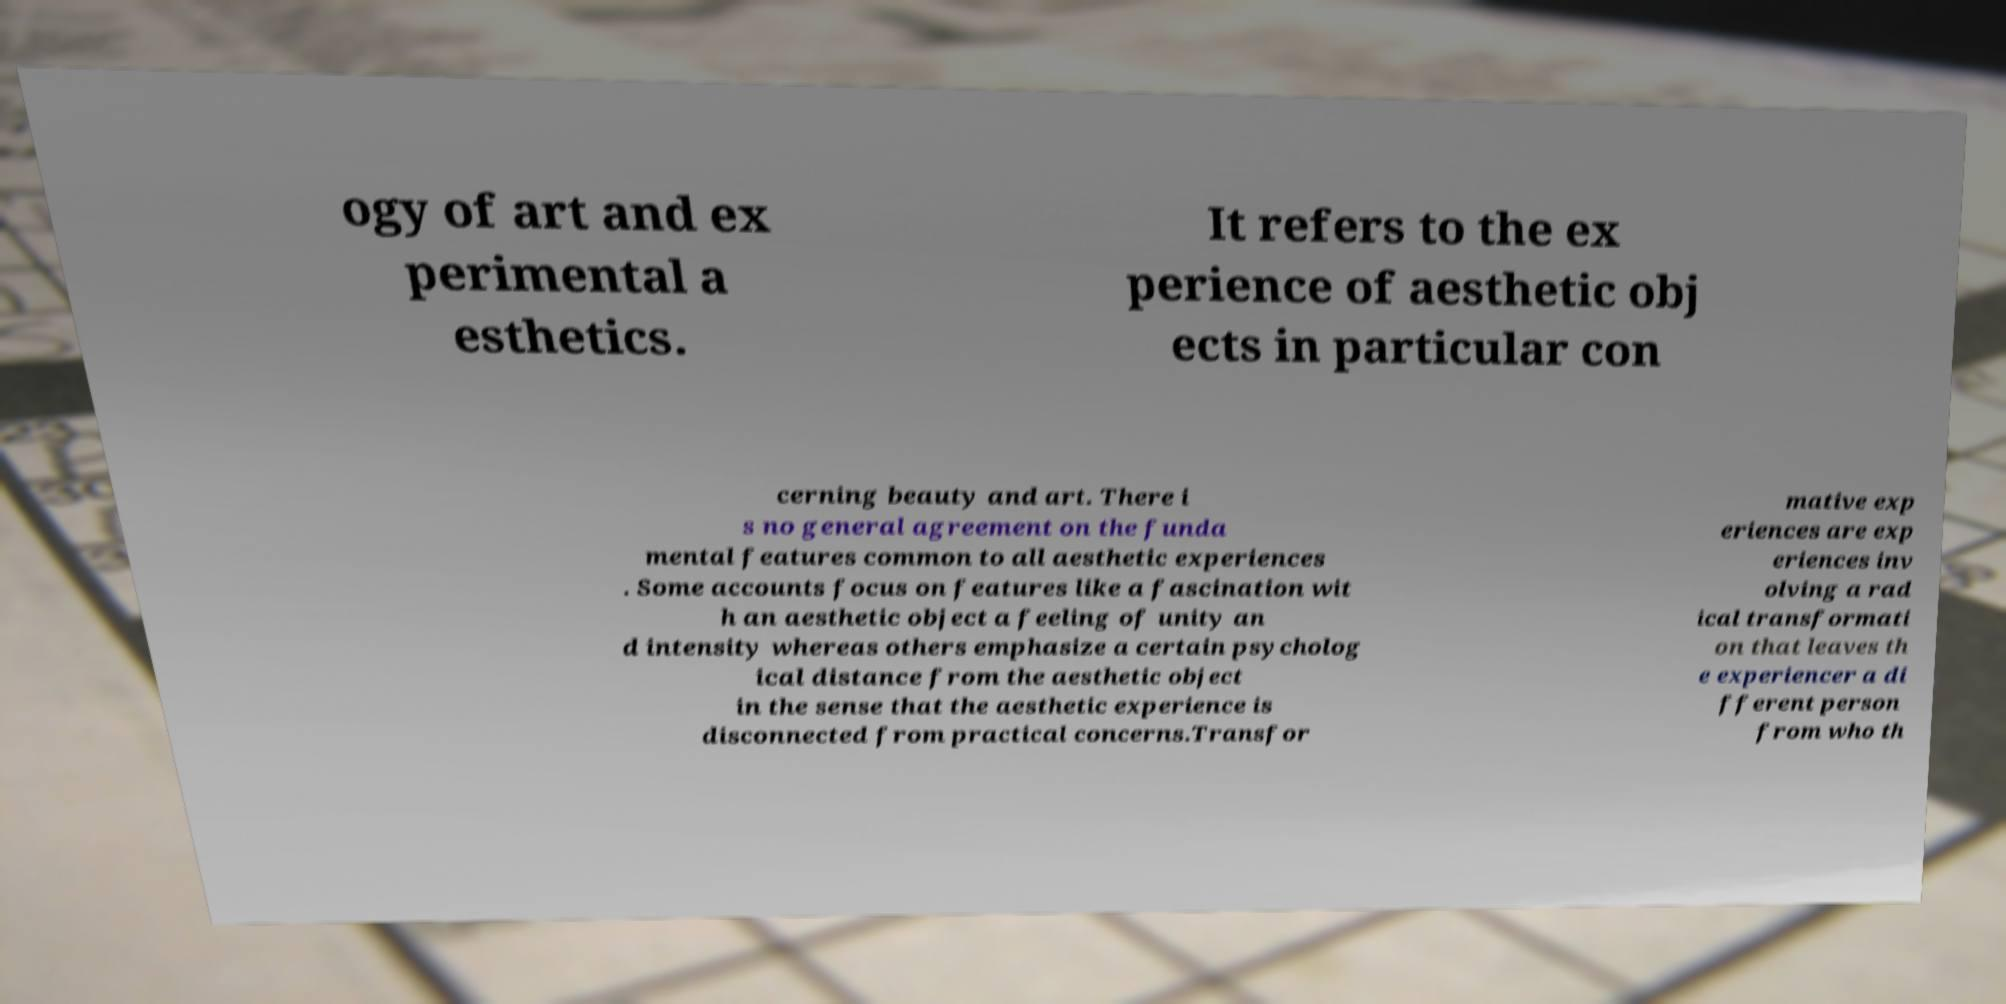Can you accurately transcribe the text from the provided image for me? ogy of art and ex perimental a esthetics. It refers to the ex perience of aesthetic obj ects in particular con cerning beauty and art. There i s no general agreement on the funda mental features common to all aesthetic experiences . Some accounts focus on features like a fascination wit h an aesthetic object a feeling of unity an d intensity whereas others emphasize a certain psycholog ical distance from the aesthetic object in the sense that the aesthetic experience is disconnected from practical concerns.Transfor mative exp eriences are exp eriences inv olving a rad ical transformati on that leaves th e experiencer a di fferent person from who th 